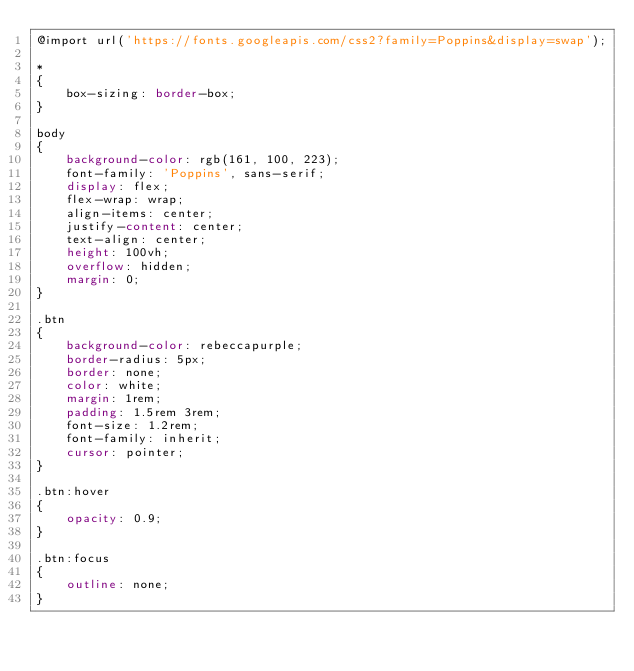<code> <loc_0><loc_0><loc_500><loc_500><_CSS_>@import url('https://fonts.googleapis.com/css2?family=Poppins&display=swap');

*
{
    box-sizing: border-box;
}

body
{
    background-color: rgb(161, 100, 223);
    font-family: 'Poppins', sans-serif;
    display: flex;
    flex-wrap: wrap;
    align-items: center;
    justify-content: center;
    text-align: center;
    height: 100vh;
    overflow: hidden;
    margin: 0;
}

.btn
{
    background-color: rebeccapurple;
    border-radius: 5px;
    border: none;
    color: white;
    margin: 1rem;
    padding: 1.5rem 3rem;
    font-size: 1.2rem;
    font-family: inherit;
    cursor: pointer;
}

.btn:hover
{
    opacity: 0.9;
}

.btn:focus
{
    outline: none;
}</code> 